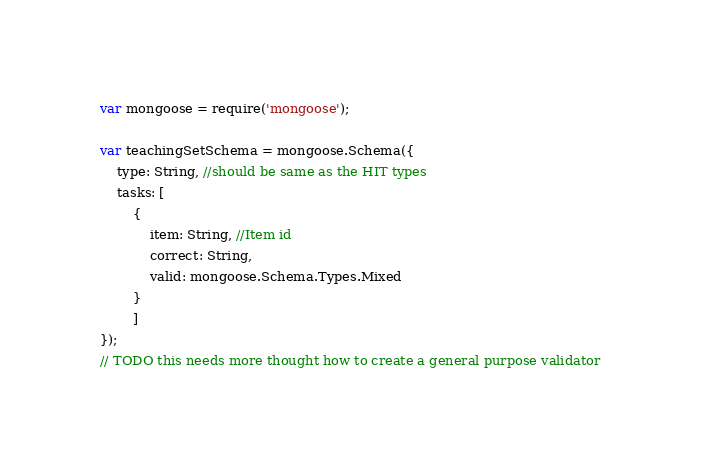<code> <loc_0><loc_0><loc_500><loc_500><_JavaScript_>var mongoose = require('mongoose');

var teachingSetSchema = mongoose.Schema({
    type: String, //should be same as the HIT types
    tasks: [
        { 
            item: String, //Item id
            correct: String,
            valid: mongoose.Schema.Types.Mixed
        }
        ]
});
// TODO this needs more thought how to create a general purpose validator
</code> 